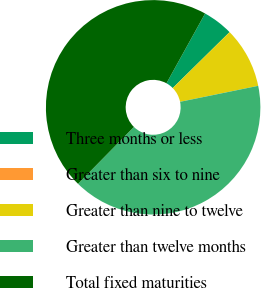<chart> <loc_0><loc_0><loc_500><loc_500><pie_chart><fcel>Three months or less<fcel>Greater than six to nine<fcel>Greater than nine to twelve<fcel>Greater than twelve months<fcel>Total fixed maturities<nl><fcel>4.58%<fcel>0.01%<fcel>9.15%<fcel>40.56%<fcel>45.69%<nl></chart> 